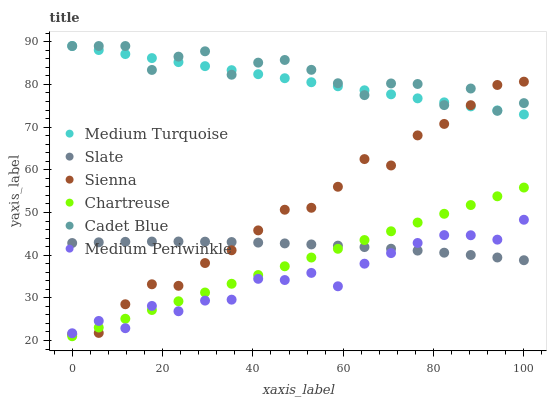Does Medium Periwinkle have the minimum area under the curve?
Answer yes or no. Yes. Does Cadet Blue have the maximum area under the curve?
Answer yes or no. Yes. Does Slate have the minimum area under the curve?
Answer yes or no. No. Does Slate have the maximum area under the curve?
Answer yes or no. No. Is Chartreuse the smoothest?
Answer yes or no. Yes. Is Cadet Blue the roughest?
Answer yes or no. Yes. Is Slate the smoothest?
Answer yes or no. No. Is Slate the roughest?
Answer yes or no. No. Does Chartreuse have the lowest value?
Answer yes or no. Yes. Does Slate have the lowest value?
Answer yes or no. No. Does Medium Turquoise have the highest value?
Answer yes or no. Yes. Does Medium Periwinkle have the highest value?
Answer yes or no. No. Is Medium Periwinkle less than Medium Turquoise?
Answer yes or no. Yes. Is Cadet Blue greater than Slate?
Answer yes or no. Yes. Does Sienna intersect Medium Periwinkle?
Answer yes or no. Yes. Is Sienna less than Medium Periwinkle?
Answer yes or no. No. Is Sienna greater than Medium Periwinkle?
Answer yes or no. No. Does Medium Periwinkle intersect Medium Turquoise?
Answer yes or no. No. 